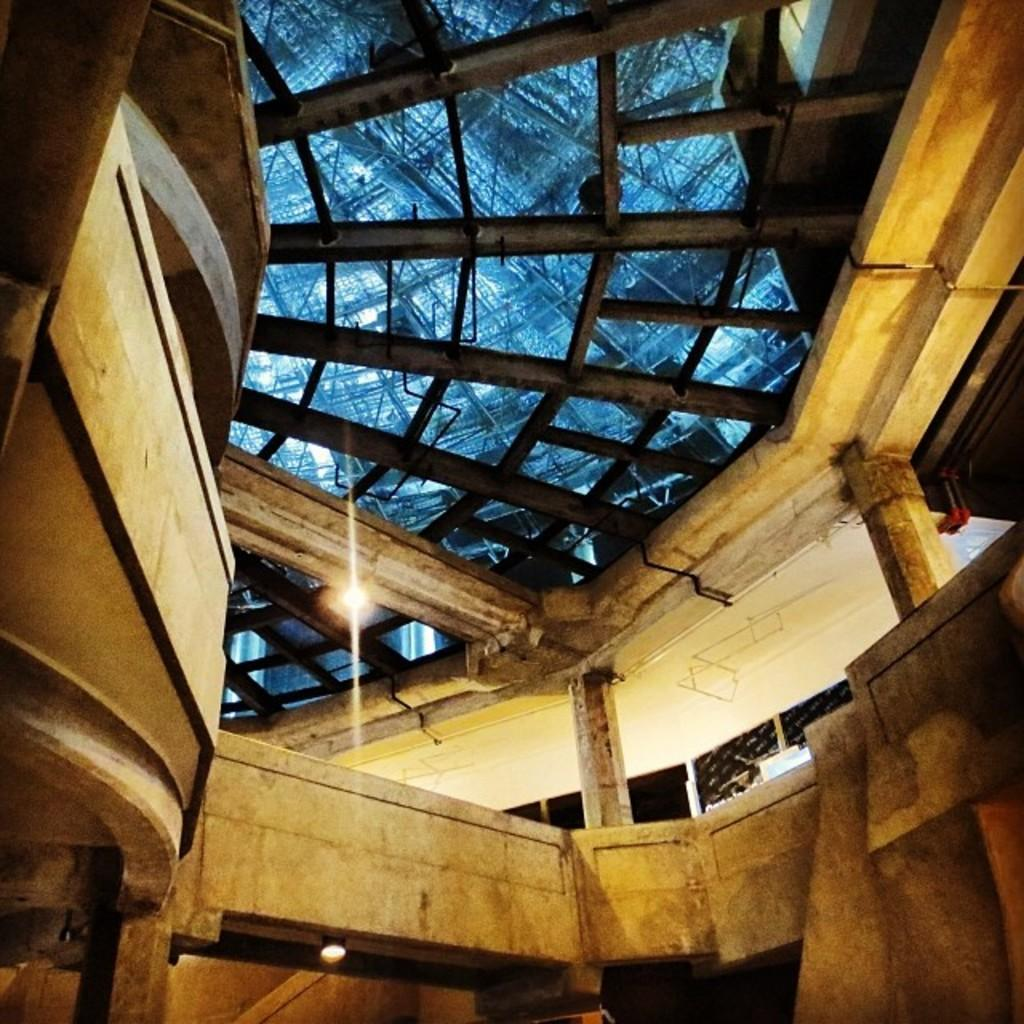What type of structure is present in the image? There is a building in the image. What material is the building made of? The building is made up of wood. Where can you find a map of the building in the image? There is no map present in the image, as it only shows a wooden building. 